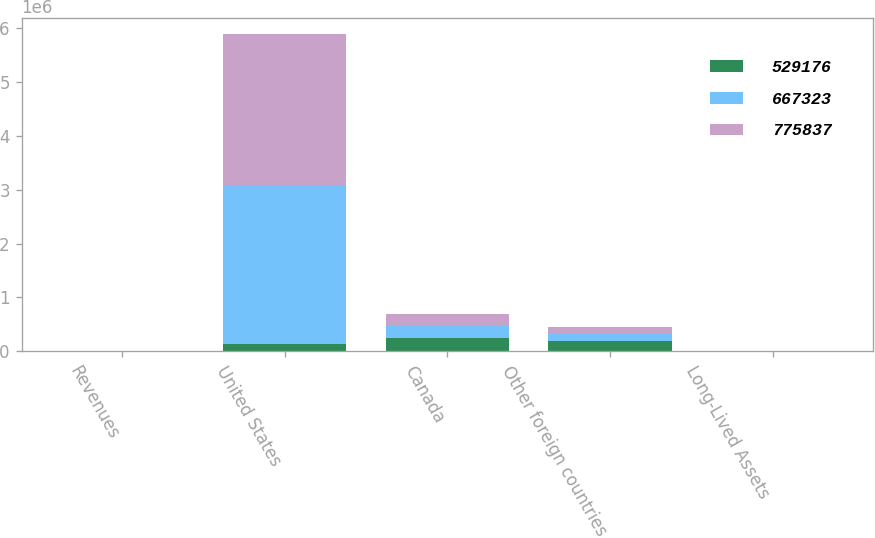Convert chart. <chart><loc_0><loc_0><loc_500><loc_500><stacked_bar_chart><ecel><fcel>Revenues<fcel>United States<fcel>Canada<fcel>Other foreign countries<fcel>Long-Lived Assets<nl><fcel>529176<fcel>2014<fcel>131780<fcel>238590<fcel>186691<fcel>2014<nl><fcel>667323<fcel>2013<fcel>2.95167e+06<fcel>227756<fcel>146677<fcel>2013<nl><fcel>775837<fcel>2012<fcel>2.79812e+06<fcel>218570<fcel>116883<fcel>2012<nl></chart> 